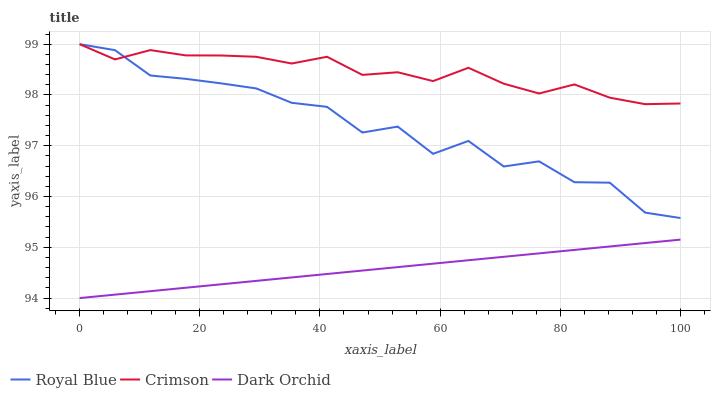Does Dark Orchid have the minimum area under the curve?
Answer yes or no. Yes. Does Crimson have the maximum area under the curve?
Answer yes or no. Yes. Does Royal Blue have the minimum area under the curve?
Answer yes or no. No. Does Royal Blue have the maximum area under the curve?
Answer yes or no. No. Is Dark Orchid the smoothest?
Answer yes or no. Yes. Is Royal Blue the roughest?
Answer yes or no. Yes. Is Royal Blue the smoothest?
Answer yes or no. No. Is Dark Orchid the roughest?
Answer yes or no. No. Does Dark Orchid have the lowest value?
Answer yes or no. Yes. Does Royal Blue have the lowest value?
Answer yes or no. No. Does Royal Blue have the highest value?
Answer yes or no. Yes. Does Dark Orchid have the highest value?
Answer yes or no. No. Is Dark Orchid less than Crimson?
Answer yes or no. Yes. Is Crimson greater than Dark Orchid?
Answer yes or no. Yes. Does Crimson intersect Royal Blue?
Answer yes or no. Yes. Is Crimson less than Royal Blue?
Answer yes or no. No. Is Crimson greater than Royal Blue?
Answer yes or no. No. Does Dark Orchid intersect Crimson?
Answer yes or no. No. 